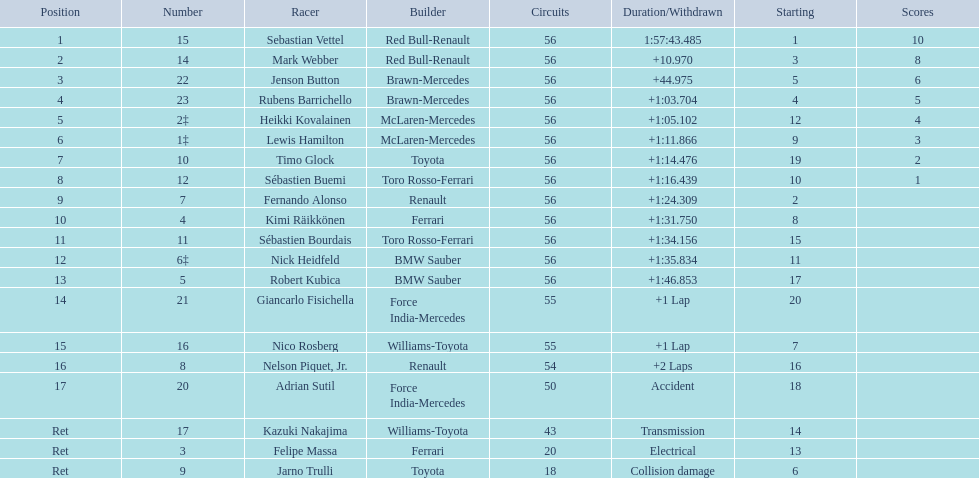Which drivers took part in the 2009 chinese grand prix? Sebastian Vettel, Mark Webber, Jenson Button, Rubens Barrichello, Heikki Kovalainen, Lewis Hamilton, Timo Glock, Sébastien Buemi, Fernando Alonso, Kimi Räikkönen, Sébastien Bourdais, Nick Heidfeld, Robert Kubica, Giancarlo Fisichella, Nico Rosberg, Nelson Piquet, Jr., Adrian Sutil, Kazuki Nakajima, Felipe Massa, Jarno Trulli. Of these, who completed all 56 laps? Sebastian Vettel, Mark Webber, Jenson Button, Rubens Barrichello, Heikki Kovalainen, Lewis Hamilton, Timo Glock, Sébastien Buemi, Fernando Alonso, Kimi Räikkönen, Sébastien Bourdais, Nick Heidfeld, Robert Kubica. Of these, which did ferrari not participate as a constructor? Sebastian Vettel, Mark Webber, Jenson Button, Rubens Barrichello, Heikki Kovalainen, Lewis Hamilton, Timo Glock, Fernando Alonso, Kimi Räikkönen, Nick Heidfeld, Robert Kubica. Of the remaining, which is in pos 1? Sebastian Vettel. 